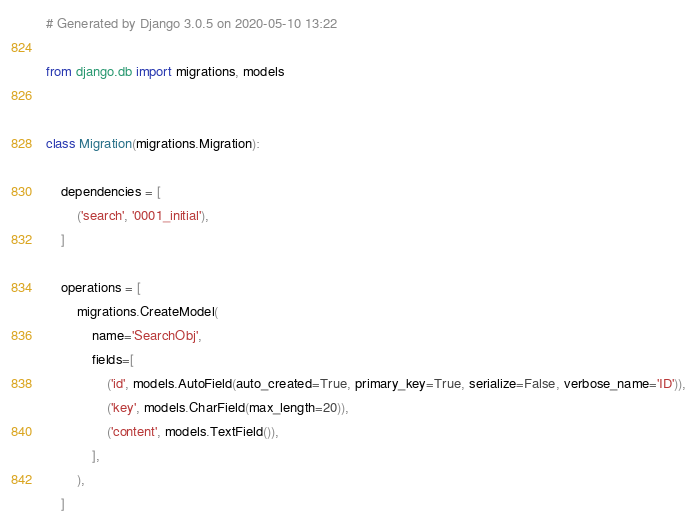Convert code to text. <code><loc_0><loc_0><loc_500><loc_500><_Python_># Generated by Django 3.0.5 on 2020-05-10 13:22

from django.db import migrations, models


class Migration(migrations.Migration):

    dependencies = [
        ('search', '0001_initial'),
    ]

    operations = [
        migrations.CreateModel(
            name='SearchObj',
            fields=[
                ('id', models.AutoField(auto_created=True, primary_key=True, serialize=False, verbose_name='ID')),
                ('key', models.CharField(max_length=20)),
                ('content', models.TextField()),
            ],
        ),
    ]
</code> 